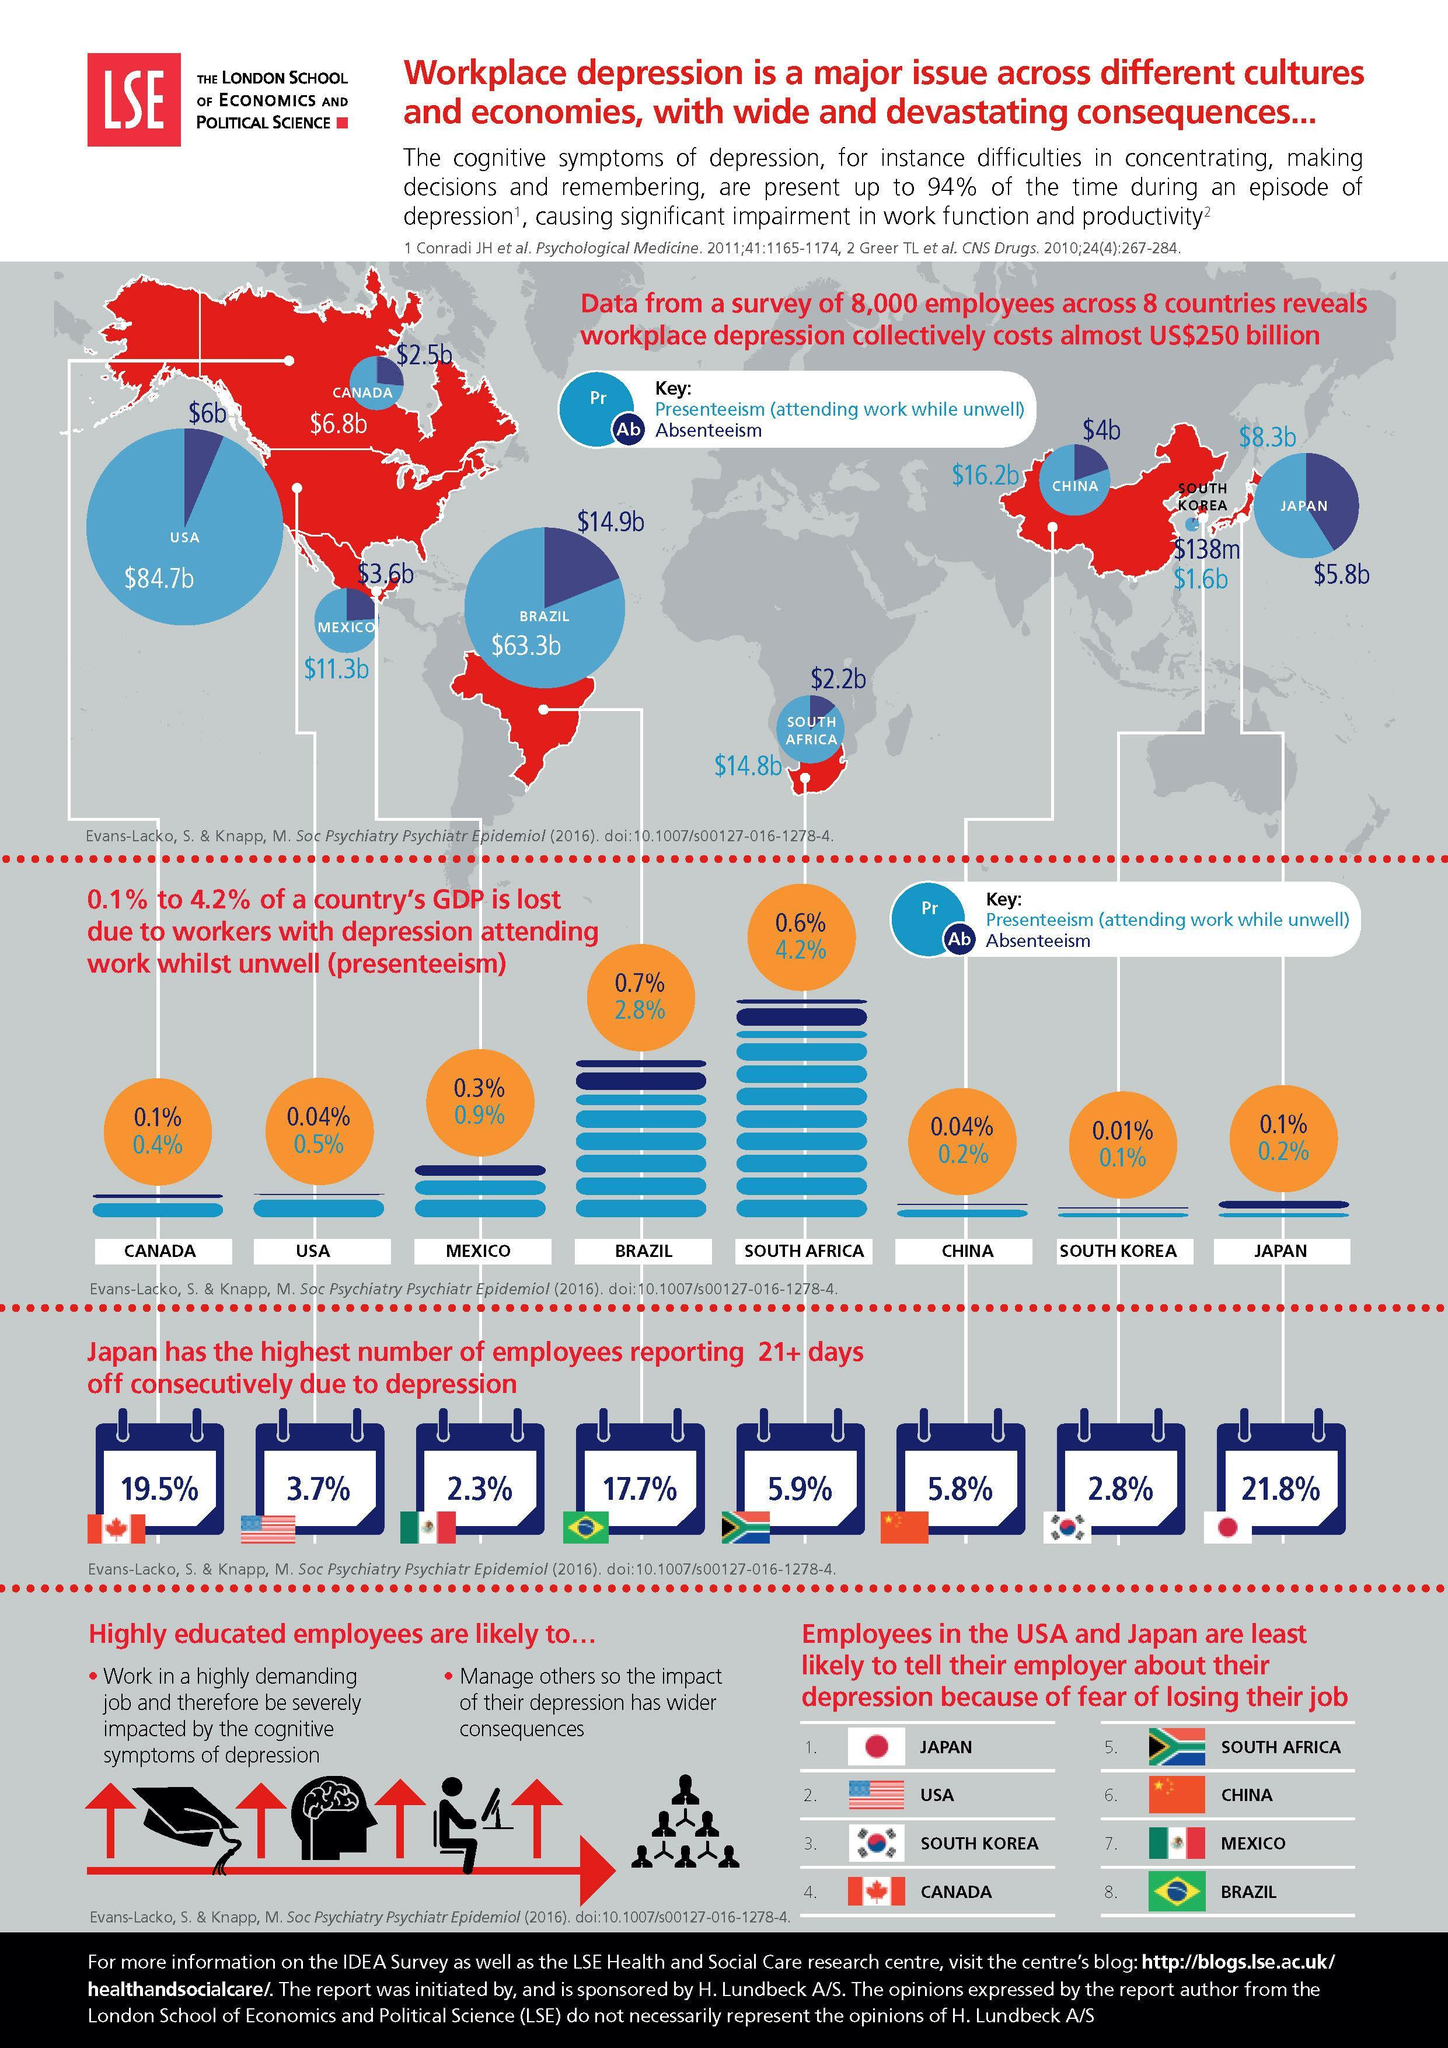What was the percentage of GDP lost by China due to presenteeism?
Answer the question with a short phrase. 0.2% Which country incurs the highest costs due to presenteeism at workplace when unwell? US Which country incurs the lowest costs due to absenteeism at workplace when unwell? South Korea What was the percentage of GDP lost by Brazil due to absenteeism? 0.7% Which country has the second highest percentage of employees taking offs due to depression? 19.5% 